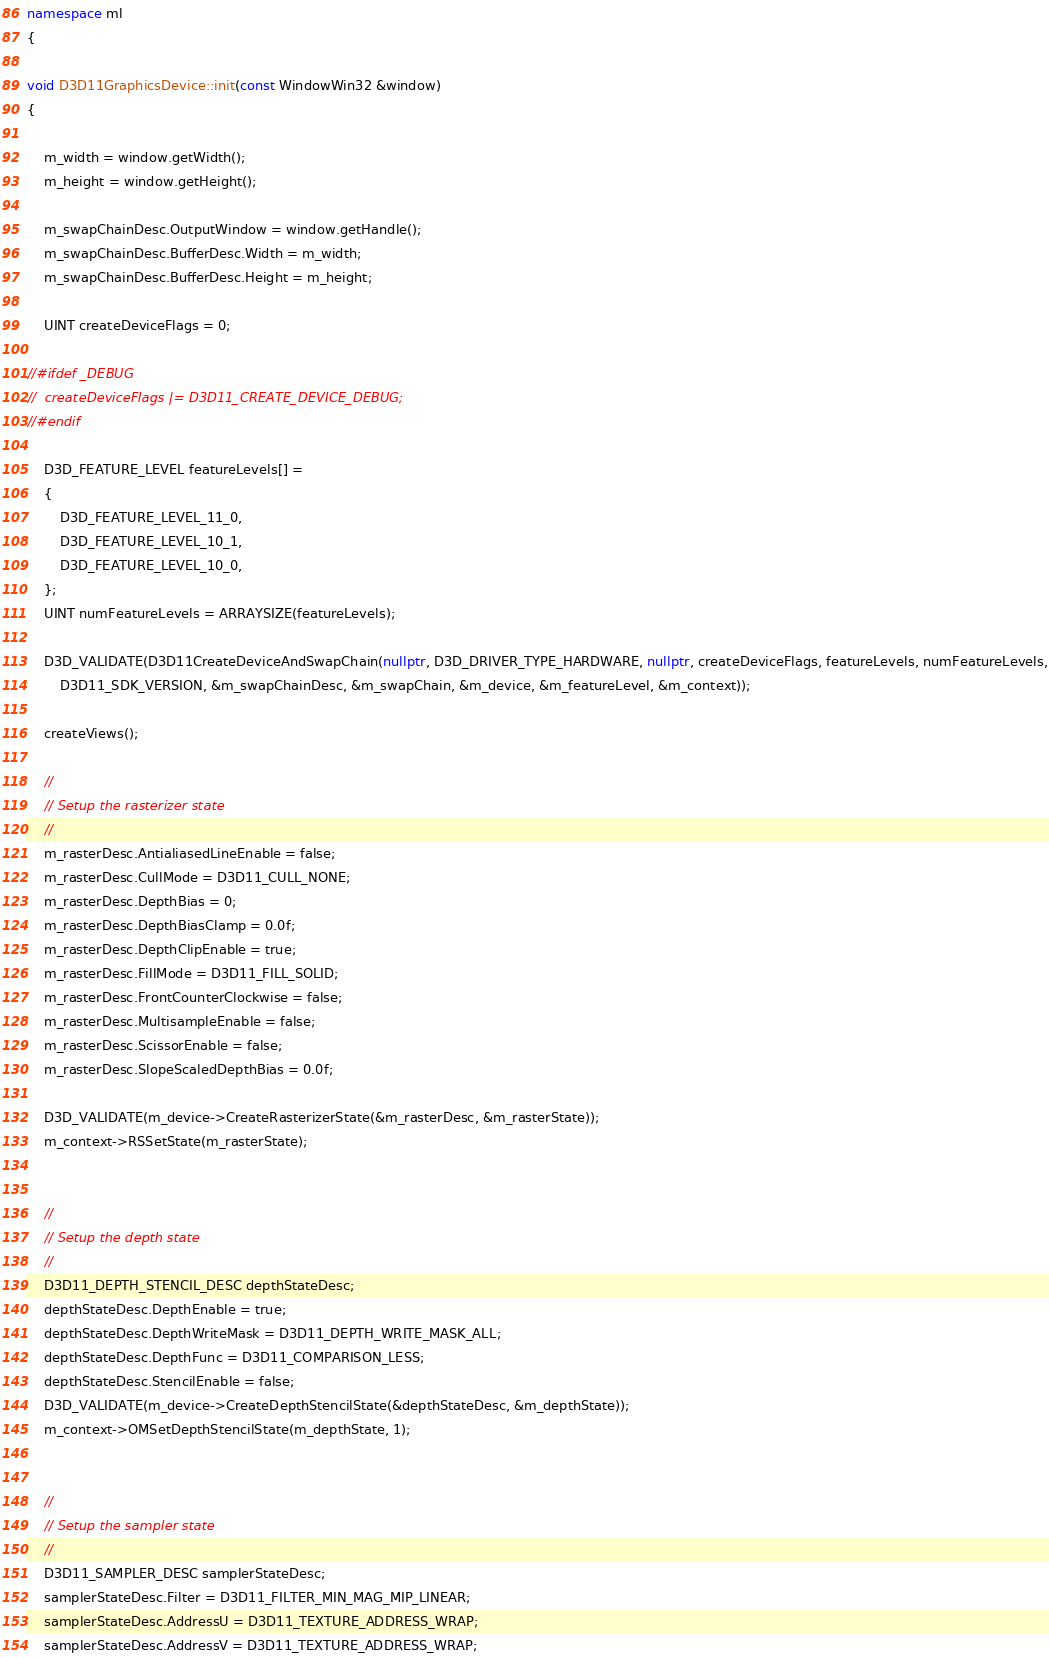Convert code to text. <code><loc_0><loc_0><loc_500><loc_500><_C++_>
namespace ml
{

void D3D11GraphicsDevice::init(const WindowWin32 &window)
{

	m_width = window.getWidth();
	m_height = window.getHeight();

	m_swapChainDesc.OutputWindow = window.getHandle();
	m_swapChainDesc.BufferDesc.Width = m_width;
	m_swapChainDesc.BufferDesc.Height = m_height;

	UINT createDeviceFlags = 0;

//#ifdef _DEBUG
//	createDeviceFlags |= D3D11_CREATE_DEVICE_DEBUG;
//#endif

    D3D_FEATURE_LEVEL featureLevels[] =
    {
        D3D_FEATURE_LEVEL_11_0,
        D3D_FEATURE_LEVEL_10_1,
        D3D_FEATURE_LEVEL_10_0,
    };
    UINT numFeatureLevels = ARRAYSIZE(featureLevels);

    D3D_VALIDATE(D3D11CreateDeviceAndSwapChain(nullptr, D3D_DRIVER_TYPE_HARDWARE, nullptr, createDeviceFlags, featureLevels, numFeatureLevels,
        D3D11_SDK_VERSION, &m_swapChainDesc, &m_swapChain, &m_device, &m_featureLevel, &m_context));

	createViews();

    //
    // Setup the rasterizer state
    //
    m_rasterDesc.AntialiasedLineEnable = false;
    m_rasterDesc.CullMode = D3D11_CULL_NONE;
    m_rasterDesc.DepthBias = 0;
    m_rasterDesc.DepthBiasClamp = 0.0f;
    m_rasterDesc.DepthClipEnable = true;
    m_rasterDesc.FillMode = D3D11_FILL_SOLID;
    m_rasterDesc.FrontCounterClockwise = false;
    m_rasterDesc.MultisampleEnable = false;
    m_rasterDesc.ScissorEnable = false;
    m_rasterDesc.SlopeScaledDepthBias = 0.0f;

    D3D_VALIDATE(m_device->CreateRasterizerState(&m_rasterDesc, &m_rasterState));
    m_context->RSSetState(m_rasterState);


    //
    // Setup the depth state
    //
    D3D11_DEPTH_STENCIL_DESC depthStateDesc;
    depthStateDesc.DepthEnable = true;
    depthStateDesc.DepthWriteMask = D3D11_DEPTH_WRITE_MASK_ALL;
    depthStateDesc.DepthFunc = D3D11_COMPARISON_LESS;
    depthStateDesc.StencilEnable = false;
    D3D_VALIDATE(m_device->CreateDepthStencilState(&depthStateDesc, &m_depthState));
    m_context->OMSetDepthStencilState(m_depthState, 1);


    //
    // Setup the sampler state
    //
    D3D11_SAMPLER_DESC samplerStateDesc;
    samplerStateDesc.Filter = D3D11_FILTER_MIN_MAG_MIP_LINEAR;
    samplerStateDesc.AddressU = D3D11_TEXTURE_ADDRESS_WRAP;
    samplerStateDesc.AddressV = D3D11_TEXTURE_ADDRESS_WRAP;</code> 